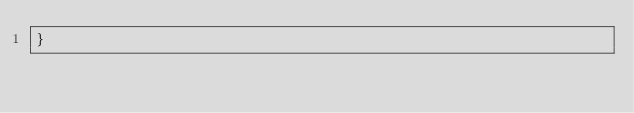<code> <loc_0><loc_0><loc_500><loc_500><_Java_>}
</code> 